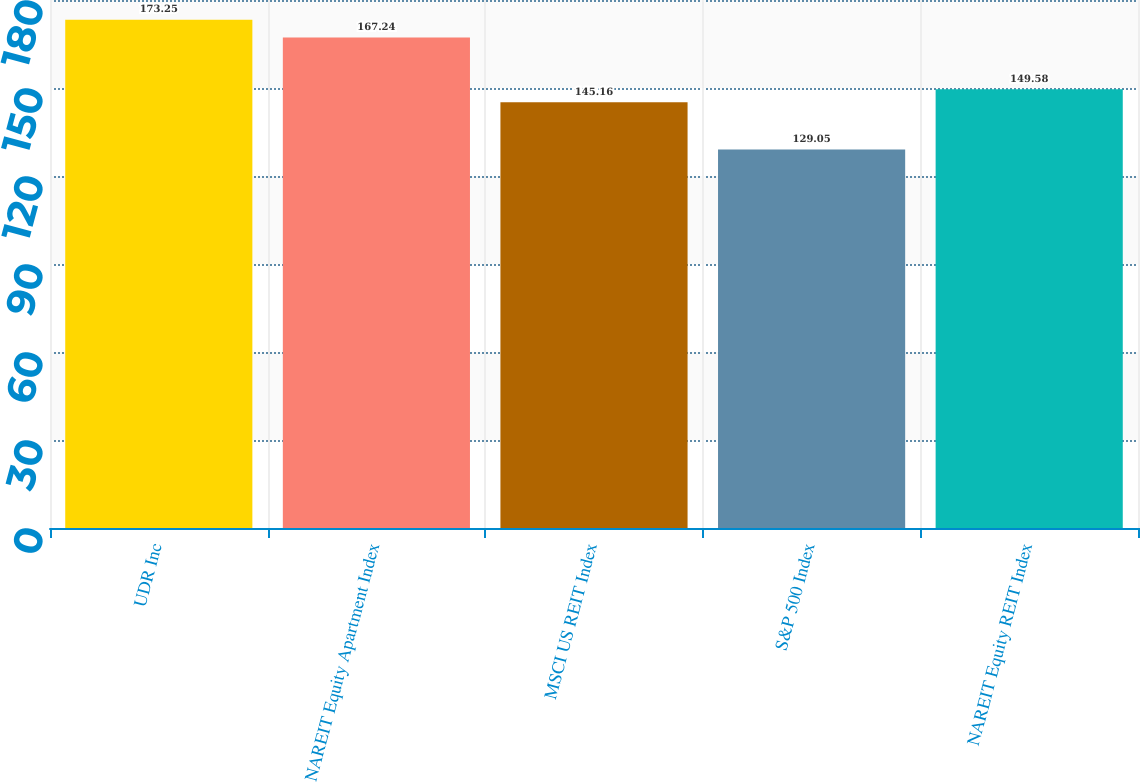<chart> <loc_0><loc_0><loc_500><loc_500><bar_chart><fcel>UDR Inc<fcel>NAREIT Equity Apartment Index<fcel>MSCI US REIT Index<fcel>S&P 500 Index<fcel>NAREIT Equity REIT Index<nl><fcel>173.25<fcel>167.24<fcel>145.16<fcel>129.05<fcel>149.58<nl></chart> 